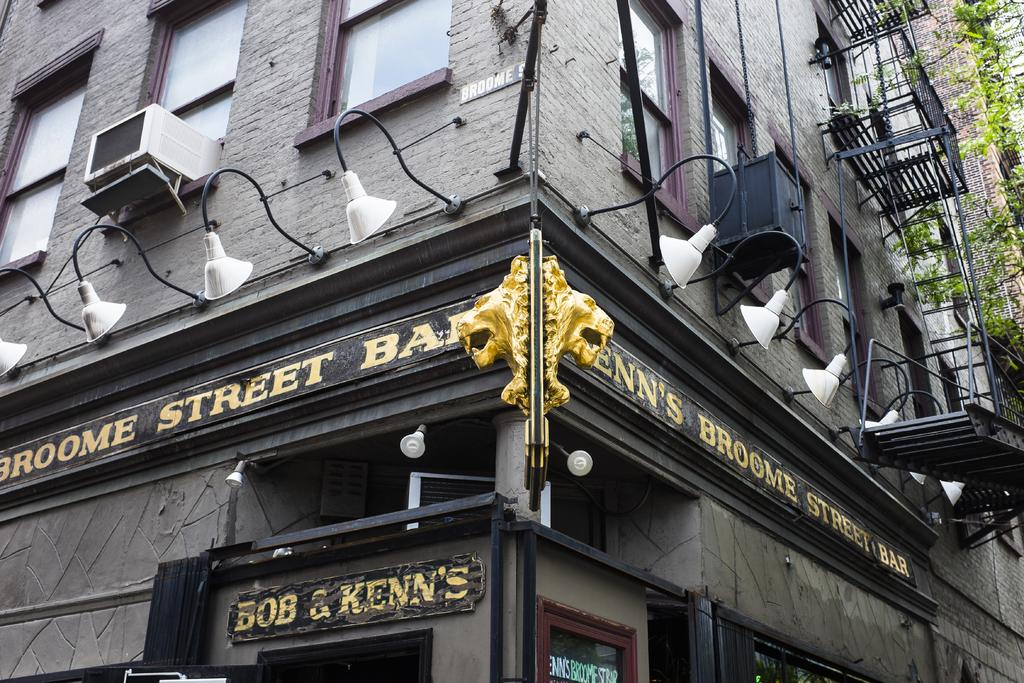What type of structure is visible in the image? There is a building in the image. What objects are present near the building? There are boards, lights, stairs, windows, and trees visible in the image. How many boats can be seen floating in the image? There are no boats present in the image. What type of bubble is visible in the image? There is no bubble present in the image. 